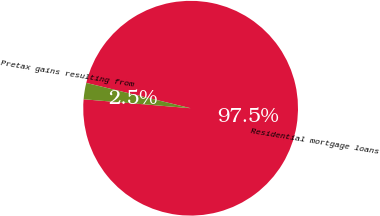<chart> <loc_0><loc_0><loc_500><loc_500><pie_chart><fcel>Residential mortgage loans<fcel>Pretax gains resulting from<nl><fcel>97.54%<fcel>2.46%<nl></chart> 